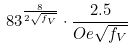Convert formula to latex. <formula><loc_0><loc_0><loc_500><loc_500>8 3 ^ { \frac { 8 } { 2 \sqrt { f _ { V } } } } \cdot \frac { 2 . 5 } { O e \sqrt { f _ { V } } }</formula> 